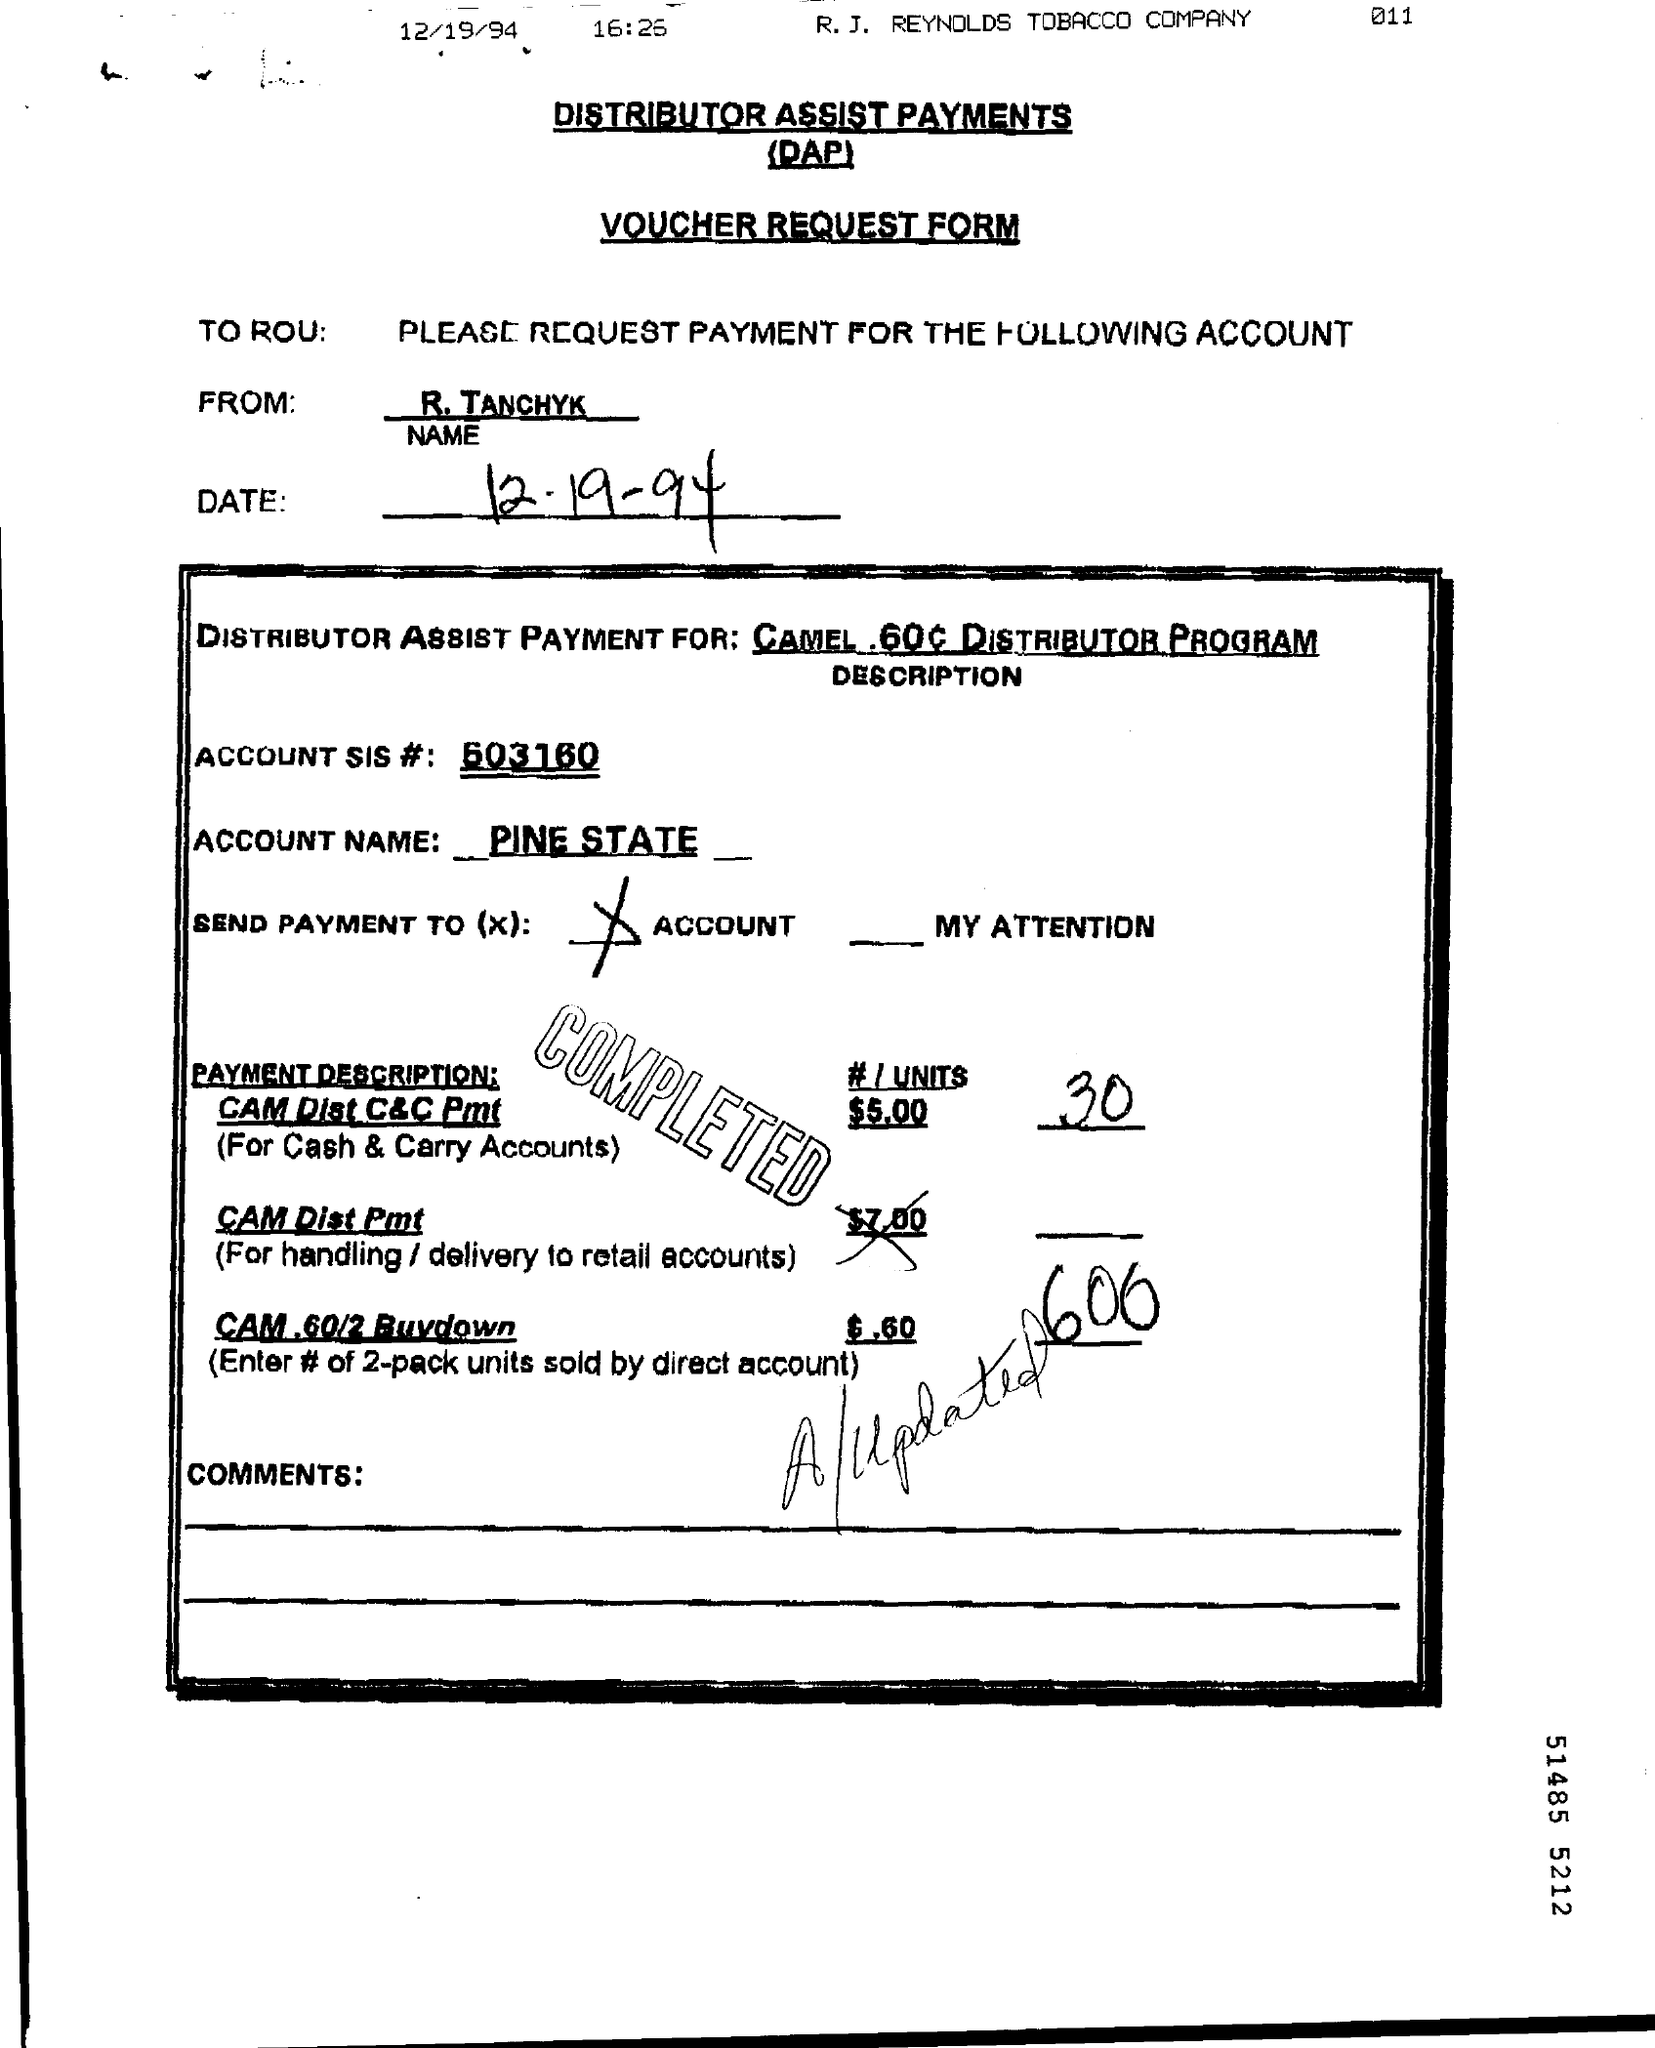What type of this Form?
Your response must be concise. Voucher Request Form. What is the Account Name ?
Give a very brief answer. PINE STATE. What is the Fullform for DAP ?
Your answer should be compact. Distributor Assist Payments. 